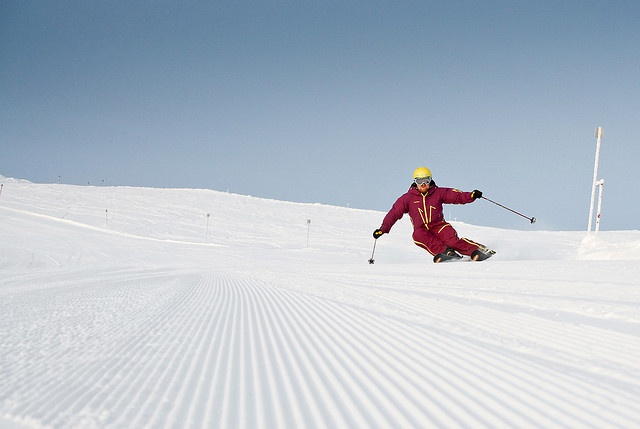Describe the objects in this image and their specific colors. I can see people in gray, maroon, brown, and black tones and skis in gray, black, darkgray, and lightgray tones in this image. 